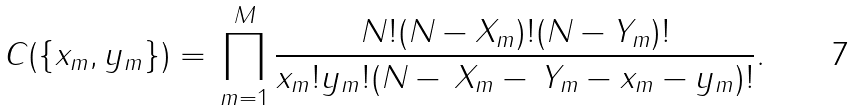Convert formula to latex. <formula><loc_0><loc_0><loc_500><loc_500>C ( \{ x _ { m } , y _ { m } \} ) = \, \prod _ { m = 1 } ^ { M } \frac { N ! ( N - X _ { m } ) ! ( N - Y _ { m } ) ! } { x _ { m } ! y _ { m } ! ( N - \, X _ { m } - \, Y _ { m } - x _ { m } - y _ { m } ) ! } .</formula> 